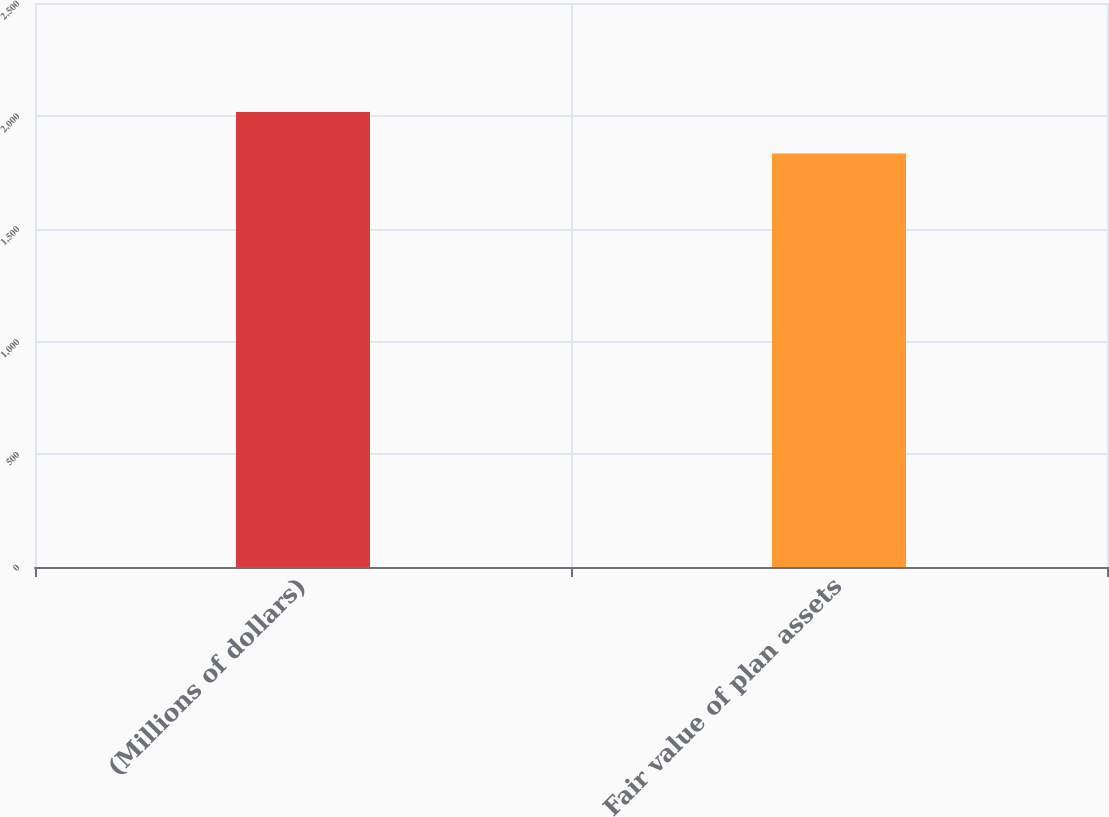Convert chart. <chart><loc_0><loc_0><loc_500><loc_500><bar_chart><fcel>(Millions of dollars)<fcel>Fair value of plan assets<nl><fcel>2017<fcel>1833<nl></chart> 